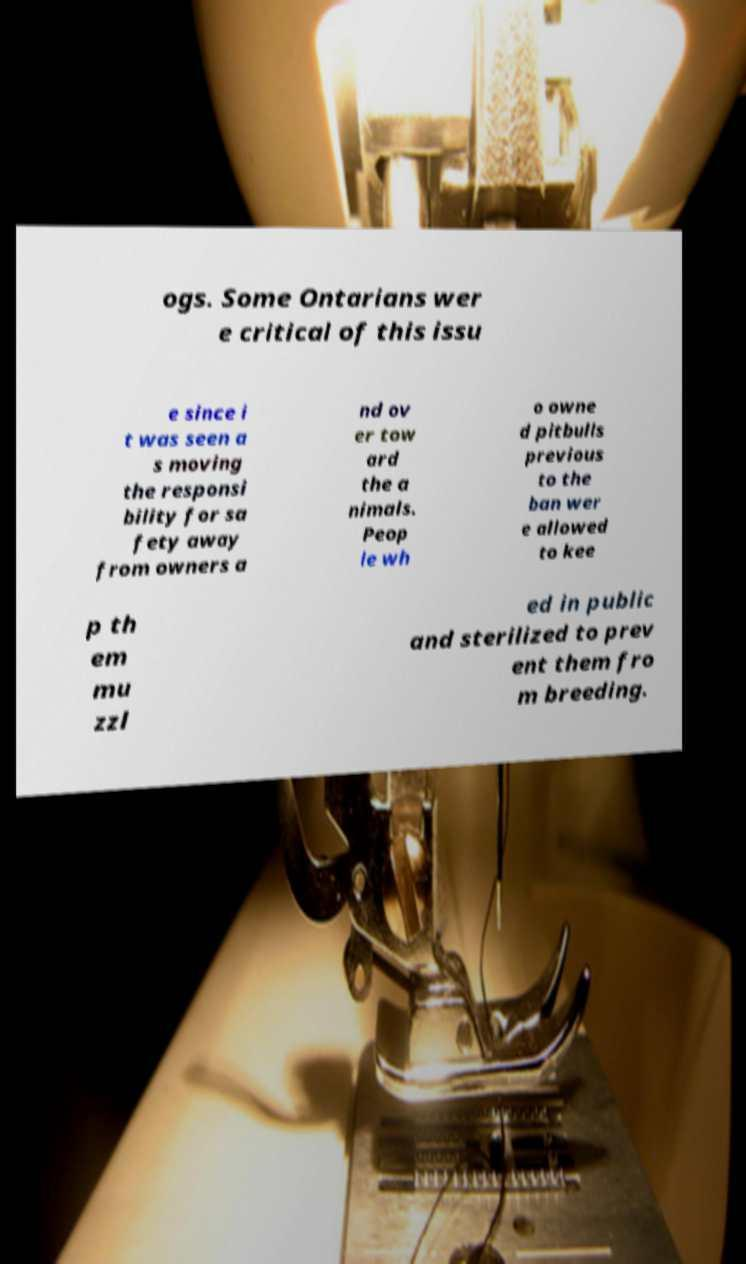I need the written content from this picture converted into text. Can you do that? ogs. Some Ontarians wer e critical of this issu e since i t was seen a s moving the responsi bility for sa fety away from owners a nd ov er tow ard the a nimals. Peop le wh o owne d pitbulls previous to the ban wer e allowed to kee p th em mu zzl ed in public and sterilized to prev ent them fro m breeding. 